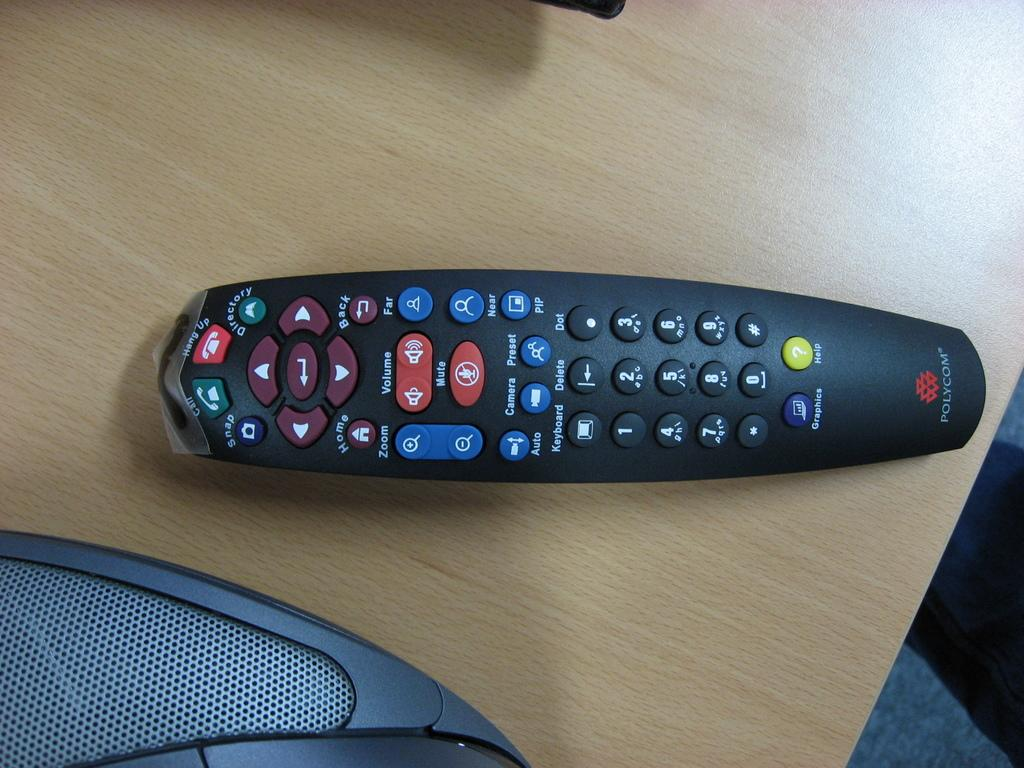<image>
Create a compact narrative representing the image presented. A black Polycom remote control laying on a wood surface. 